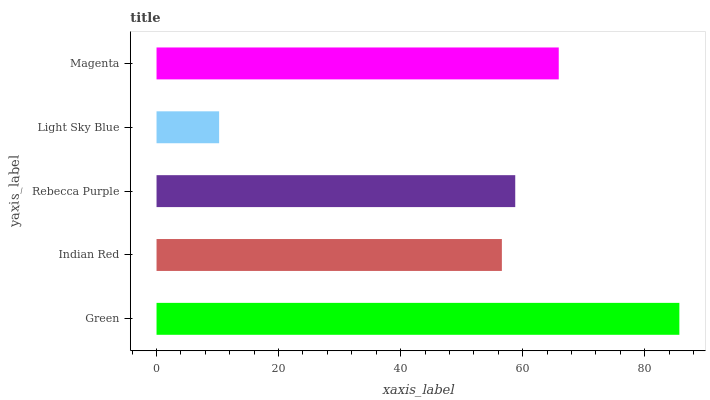Is Light Sky Blue the minimum?
Answer yes or no. Yes. Is Green the maximum?
Answer yes or no. Yes. Is Indian Red the minimum?
Answer yes or no. No. Is Indian Red the maximum?
Answer yes or no. No. Is Green greater than Indian Red?
Answer yes or no. Yes. Is Indian Red less than Green?
Answer yes or no. Yes. Is Indian Red greater than Green?
Answer yes or no. No. Is Green less than Indian Red?
Answer yes or no. No. Is Rebecca Purple the high median?
Answer yes or no. Yes. Is Rebecca Purple the low median?
Answer yes or no. Yes. Is Magenta the high median?
Answer yes or no. No. Is Light Sky Blue the low median?
Answer yes or no. No. 